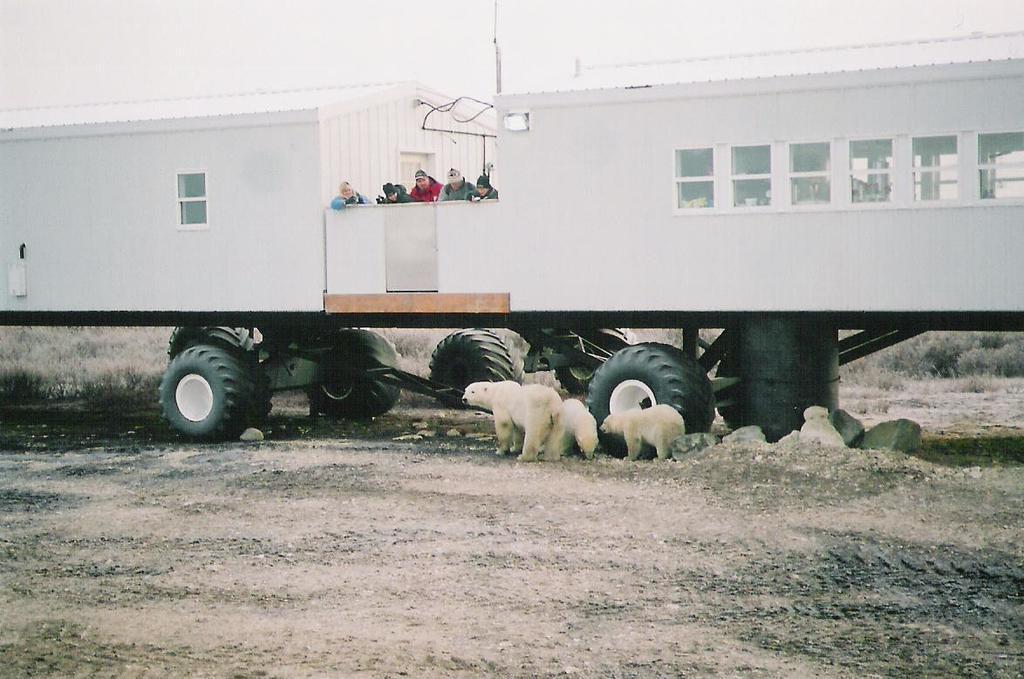Describe this image in one or two sentences. In this image there is a vehicle on the ground. There are a few people standing on the vehicle. Beside the vehicle there are a few polar bears on the ground. At the bottom there is the ground. There are plants and small rocks on the ground. At the top there is the sky. 